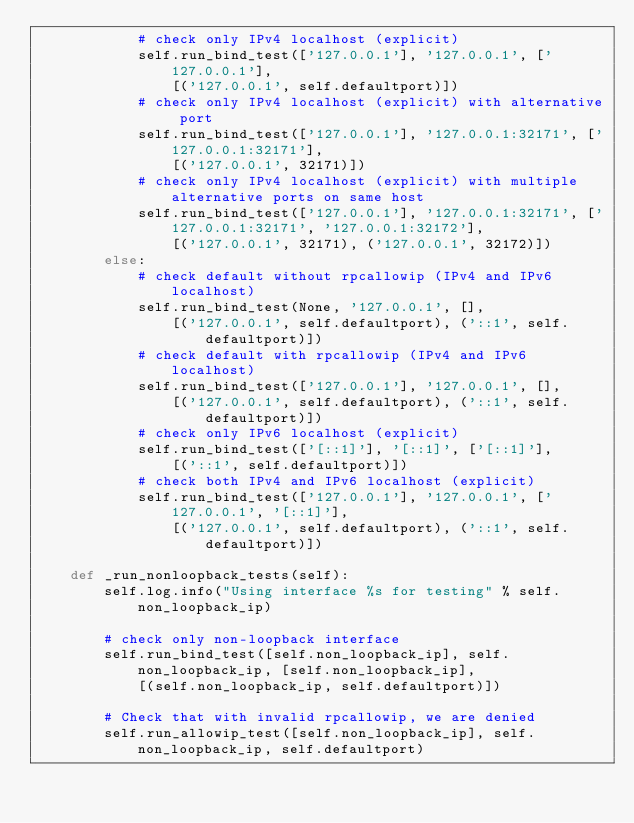Convert code to text. <code><loc_0><loc_0><loc_500><loc_500><_Python_>            # check only IPv4 localhost (explicit)
            self.run_bind_test(['127.0.0.1'], '127.0.0.1', ['127.0.0.1'],
                [('127.0.0.1', self.defaultport)])
            # check only IPv4 localhost (explicit) with alternative port
            self.run_bind_test(['127.0.0.1'], '127.0.0.1:32171', ['127.0.0.1:32171'],
                [('127.0.0.1', 32171)])
            # check only IPv4 localhost (explicit) with multiple alternative ports on same host
            self.run_bind_test(['127.0.0.1'], '127.0.0.1:32171', ['127.0.0.1:32171', '127.0.0.1:32172'],
                [('127.0.0.1', 32171), ('127.0.0.1', 32172)])
        else:
            # check default without rpcallowip (IPv4 and IPv6 localhost)
            self.run_bind_test(None, '127.0.0.1', [],
                [('127.0.0.1', self.defaultport), ('::1', self.defaultport)])
            # check default with rpcallowip (IPv4 and IPv6 localhost)
            self.run_bind_test(['127.0.0.1'], '127.0.0.1', [],
                [('127.0.0.1', self.defaultport), ('::1', self.defaultport)])
            # check only IPv6 localhost (explicit)
            self.run_bind_test(['[::1]'], '[::1]', ['[::1]'],
                [('::1', self.defaultport)])
            # check both IPv4 and IPv6 localhost (explicit)
            self.run_bind_test(['127.0.0.1'], '127.0.0.1', ['127.0.0.1', '[::1]'],
                [('127.0.0.1', self.defaultport), ('::1', self.defaultport)])

    def _run_nonloopback_tests(self):
        self.log.info("Using interface %s for testing" % self.non_loopback_ip)

        # check only non-loopback interface
        self.run_bind_test([self.non_loopback_ip], self.non_loopback_ip, [self.non_loopback_ip],
            [(self.non_loopback_ip, self.defaultport)])

        # Check that with invalid rpcallowip, we are denied
        self.run_allowip_test([self.non_loopback_ip], self.non_loopback_ip, self.defaultport)</code> 